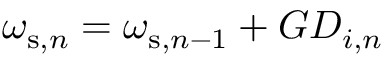<formula> <loc_0><loc_0><loc_500><loc_500>\omega _ { s , n } = \omega _ { s , n - 1 } + G D _ { i , n }</formula> 